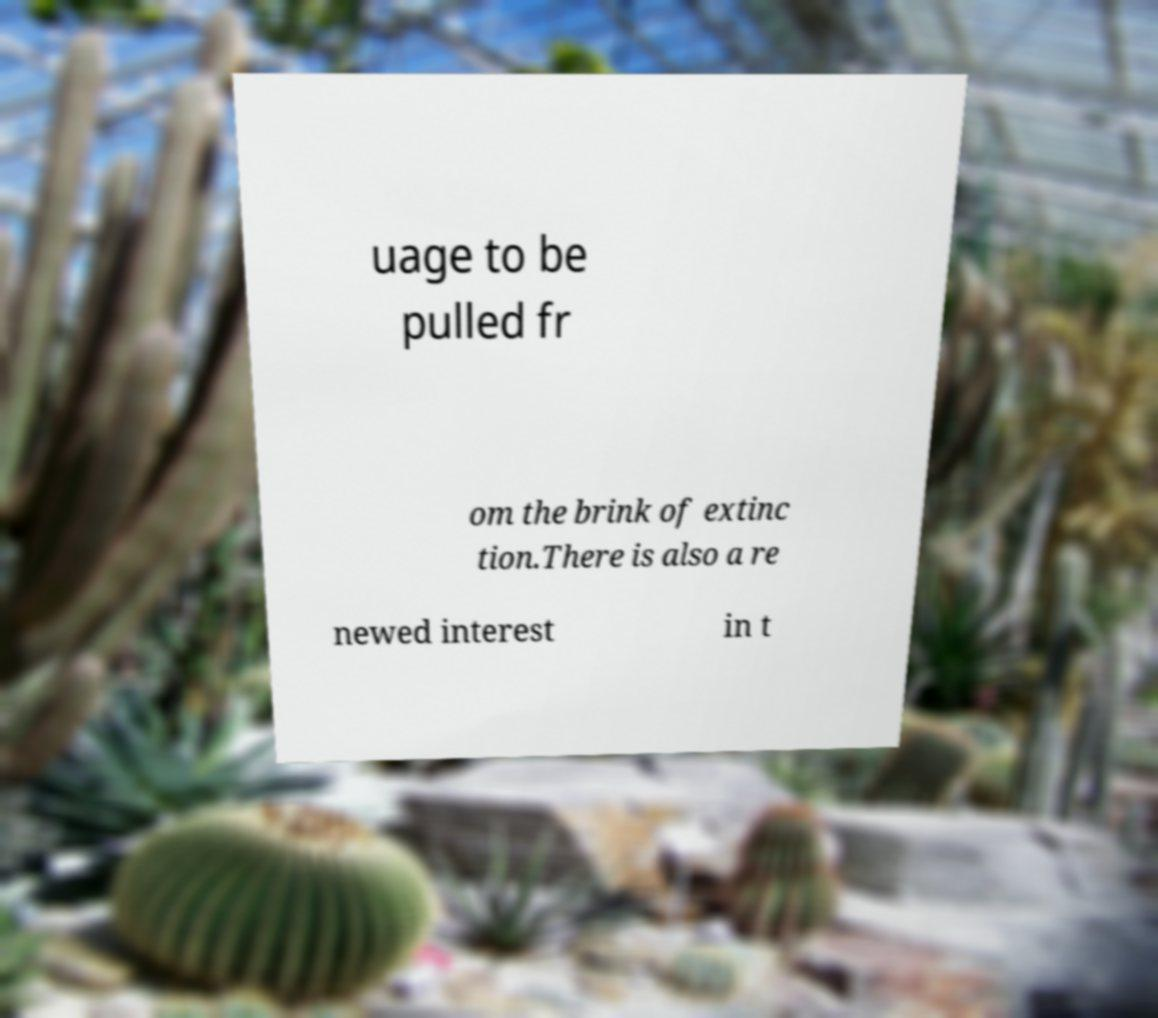For documentation purposes, I need the text within this image transcribed. Could you provide that? uage to be pulled fr om the brink of extinc tion.There is also a re newed interest in t 